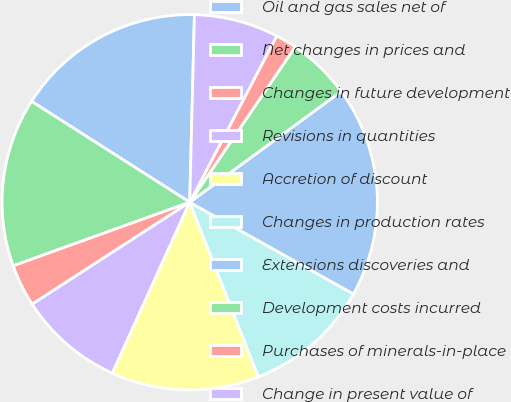<chart> <loc_0><loc_0><loc_500><loc_500><pie_chart><fcel>Oil and gas sales net of<fcel>Net changes in prices and<fcel>Changes in future development<fcel>Revisions in quantities<fcel>Accretion of discount<fcel>Changes in production rates<fcel>Extensions discoveries and<fcel>Development costs incurred<fcel>Purchases of minerals-in-place<fcel>Change in present value of<nl><fcel>16.36%<fcel>14.54%<fcel>3.64%<fcel>9.09%<fcel>12.73%<fcel>10.91%<fcel>18.18%<fcel>5.46%<fcel>1.82%<fcel>7.27%<nl></chart> 